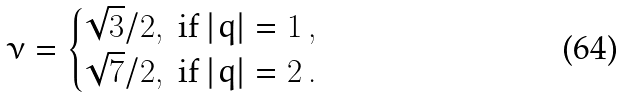Convert formula to latex. <formula><loc_0><loc_0><loc_500><loc_500>\nu = \begin{cases} \sqrt { 3 } / 2 , \text { if } | q | = 1 \, , \\ \sqrt { 7 } / 2 , \text { if } | q | = 2 \, . \end{cases}</formula> 